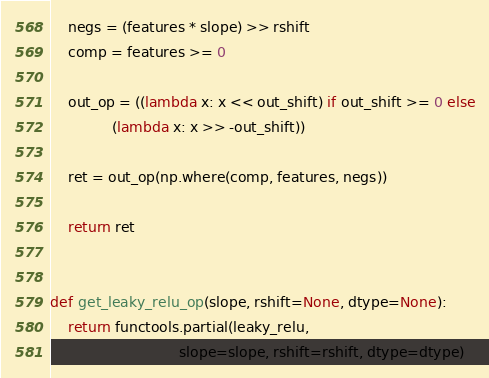Convert code to text. <code><loc_0><loc_0><loc_500><loc_500><_Python_>    negs = (features * slope) >> rshift
    comp = features >= 0

    out_op = ((lambda x: x << out_shift) if out_shift >= 0 else
              (lambda x: x >> -out_shift))

    ret = out_op(np.where(comp, features, negs))

    return ret


def get_leaky_relu_op(slope, rshift=None, dtype=None):
    return functools.partial(leaky_relu,
                             slope=slope, rshift=rshift, dtype=dtype)
</code> 